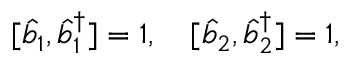Convert formula to latex. <formula><loc_0><loc_0><loc_500><loc_500>[ \hat { b } _ { 1 } , \hat { b } _ { 1 } ^ { \dagger } ] = 1 , \quad [ \hat { b } _ { 2 } , \hat { b } _ { 2 } ^ { \dagger } ] = 1 ,</formula> 